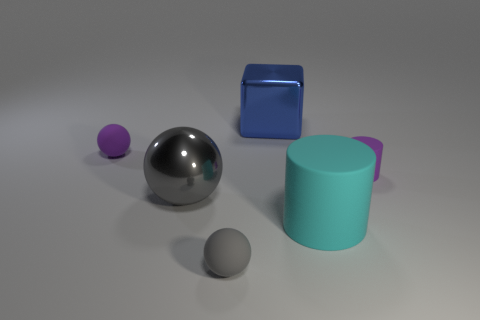Subtract all cyan cylinders. How many gray balls are left? 2 Subtract all gray balls. How many balls are left? 1 Add 2 big metal things. How many objects exist? 8 Subtract all cylinders. How many objects are left? 4 Subtract all small cyan shiny objects. Subtract all gray shiny things. How many objects are left? 5 Add 4 large gray objects. How many large gray objects are left? 5 Add 2 gray blocks. How many gray blocks exist? 2 Subtract 0 green cubes. How many objects are left? 6 